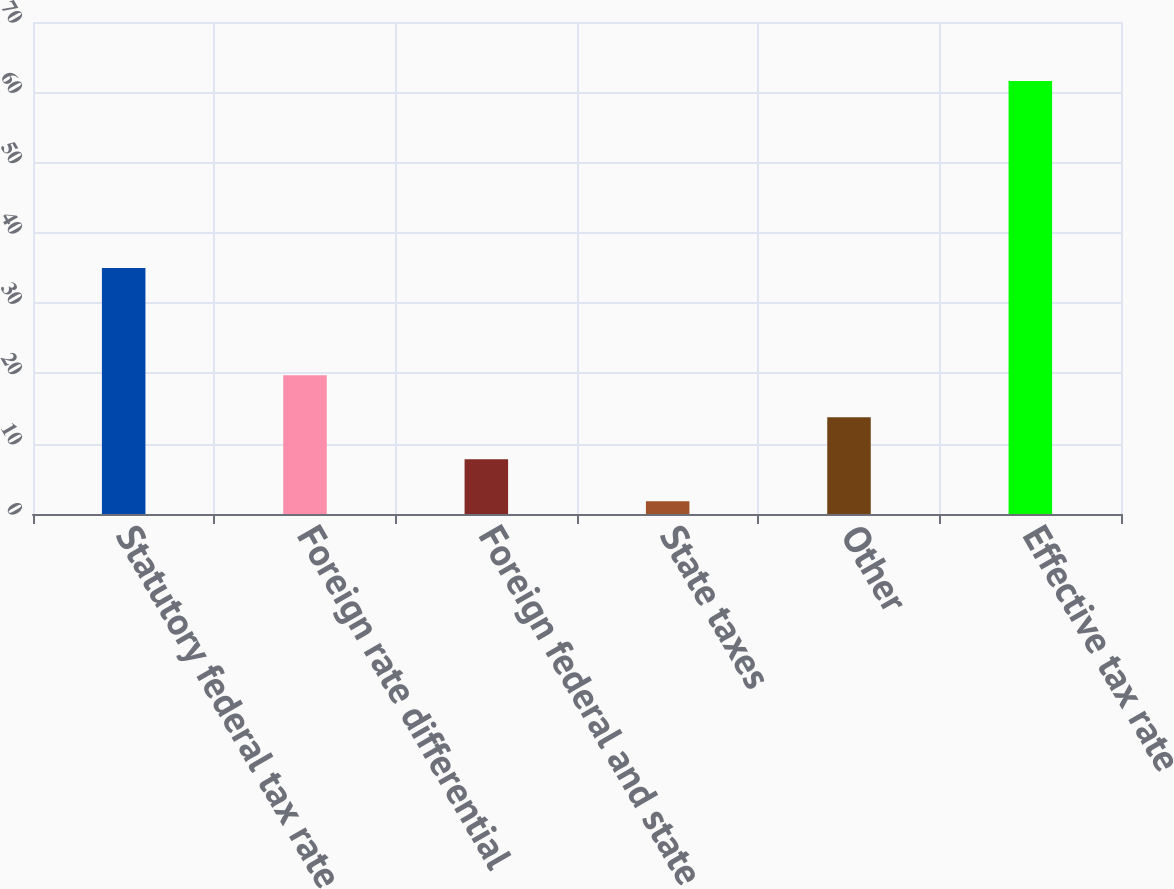Convert chart to OTSL. <chart><loc_0><loc_0><loc_500><loc_500><bar_chart><fcel>Statutory federal tax rate<fcel>Foreign rate differential<fcel>Foreign federal and state<fcel>State taxes<fcel>Other<fcel>Effective tax rate<nl><fcel>35<fcel>19.74<fcel>7.78<fcel>1.8<fcel>13.76<fcel>61.6<nl></chart> 